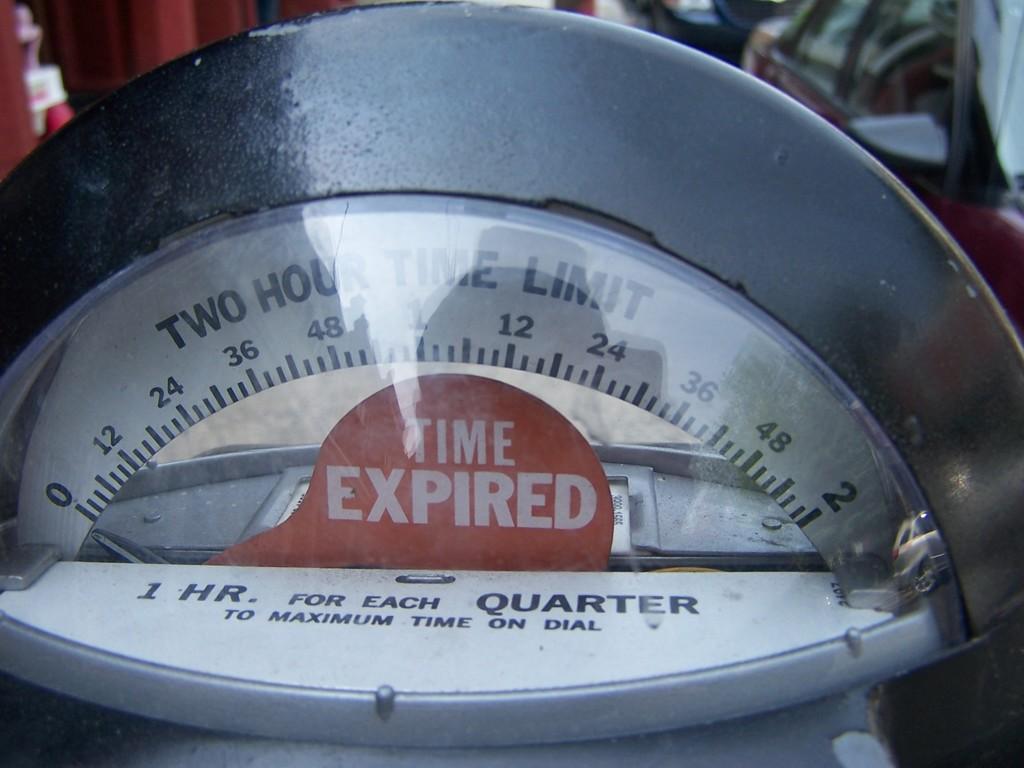How much for an hour?
Offer a very short reply. Quarter. 